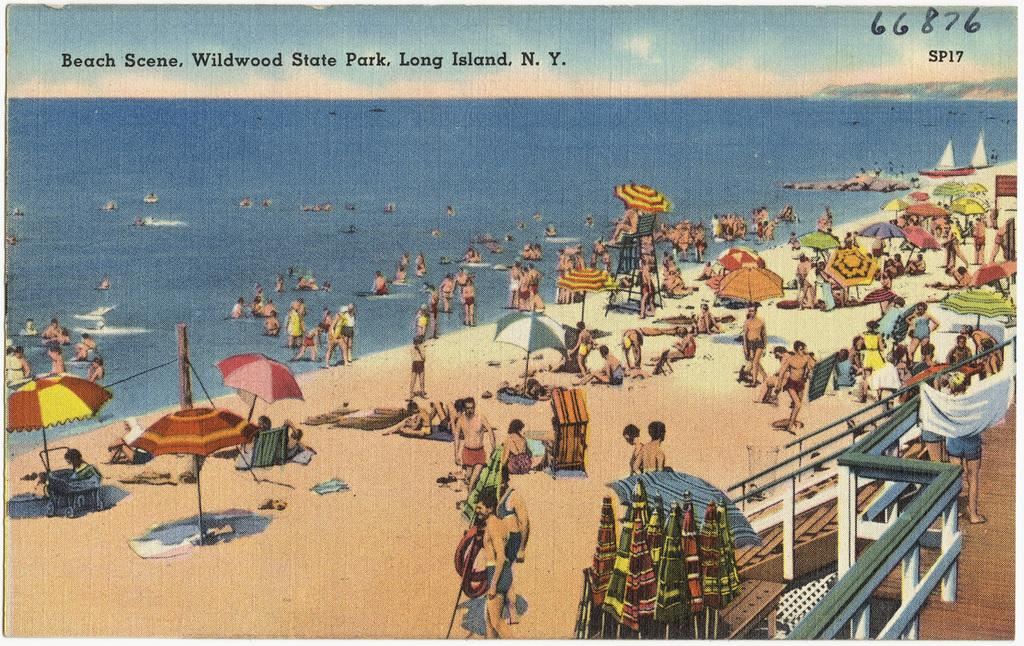<image>
Provide a brief description of the given image. Postcard of Wildwood State Park Beach in Long Island New York # 66876. 